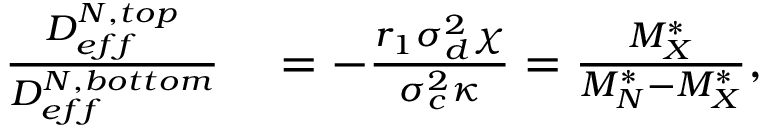Convert formula to latex. <formula><loc_0><loc_0><loc_500><loc_500>\begin{array} { r l } { \frac { D _ { e f f } ^ { N , t o p } } { D _ { e f f } ^ { N , b o t t o m } } } & = - \frac { r _ { 1 } \sigma _ { d } ^ { 2 } \chi } { \sigma _ { c } ^ { 2 } \kappa } = \frac { M _ { X } ^ { * } } { M _ { N } ^ { * } - M _ { X } ^ { * } } , } \end{array}</formula> 